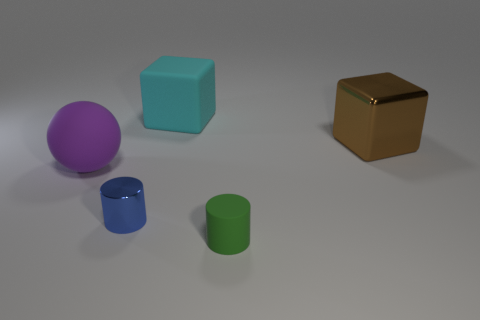What number of things are large matte objects that are in front of the metallic cube or blue metal cylinders?
Your response must be concise. 2. Are there the same number of purple matte spheres that are on the right side of the tiny metallic cylinder and blue shiny things that are on the left side of the big brown thing?
Your response must be concise. No. The small green cylinder in front of the big rubber thing that is left of the small cylinder to the left of the small green cylinder is made of what material?
Offer a terse response. Rubber. What is the size of the matte object that is both right of the tiny blue object and in front of the cyan block?
Your answer should be compact. Small. Is the purple object the same shape as the cyan thing?
Your response must be concise. No. What shape is the small object that is the same material as the large cyan object?
Make the answer very short. Cylinder. How many small objects are either green matte cubes or cylinders?
Make the answer very short. 2. Are there any shiny objects left of the large block that is in front of the big cyan rubber block?
Make the answer very short. Yes. Are there any blue metallic objects?
Provide a short and direct response. Yes. What is the color of the large object that is on the right side of the large cube left of the green matte cylinder?
Your answer should be very brief. Brown. 